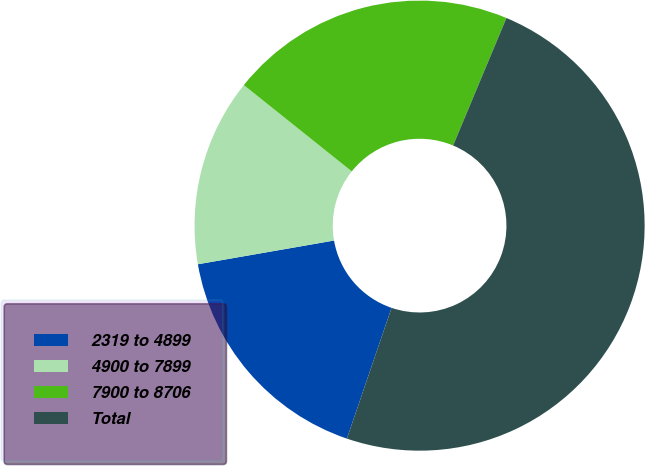Convert chart. <chart><loc_0><loc_0><loc_500><loc_500><pie_chart><fcel>2319 to 4899<fcel>4900 to 7899<fcel>7900 to 8706<fcel>Total<nl><fcel>17.02%<fcel>13.48%<fcel>20.57%<fcel>48.93%<nl></chart> 